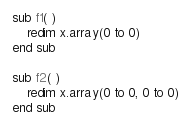<code> <loc_0><loc_0><loc_500><loc_500><_VisualBasic_>sub f1( )
	redim x.array(0 to 0)
end sub

sub f2( )
	redim x.array(0 to 0, 0 to 0)
end sub
</code> 